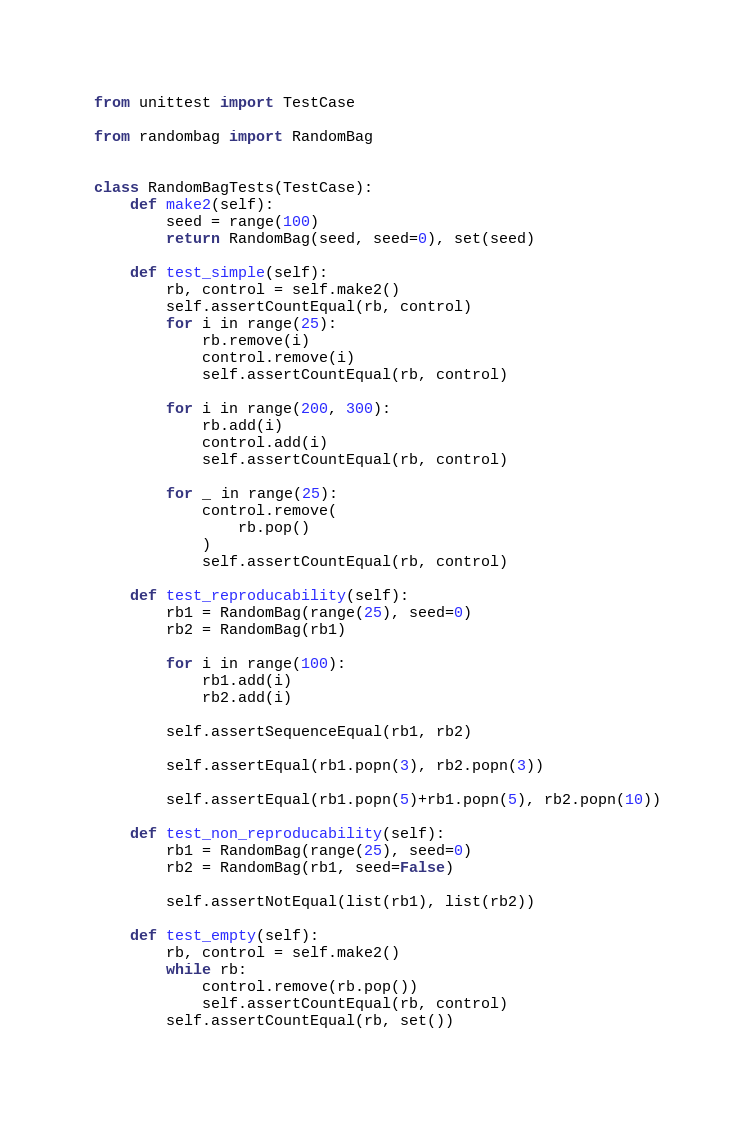Convert code to text. <code><loc_0><loc_0><loc_500><loc_500><_Python_>from unittest import TestCase

from randombag import RandomBag


class RandomBagTests(TestCase):
    def make2(self):
        seed = range(100)
        return RandomBag(seed, seed=0), set(seed)

    def test_simple(self):
        rb, control = self.make2()
        self.assertCountEqual(rb, control)
        for i in range(25):
            rb.remove(i)
            control.remove(i)
            self.assertCountEqual(rb, control)

        for i in range(200, 300):
            rb.add(i)
            control.add(i)
            self.assertCountEqual(rb, control)

        for _ in range(25):
            control.remove(
                rb.pop()
            )
            self.assertCountEqual(rb, control)

    def test_reproducability(self):
        rb1 = RandomBag(range(25), seed=0)
        rb2 = RandomBag(rb1)

        for i in range(100):
            rb1.add(i)
            rb2.add(i)

        self.assertSequenceEqual(rb1, rb2)

        self.assertEqual(rb1.popn(3), rb2.popn(3))

        self.assertEqual(rb1.popn(5)+rb1.popn(5), rb2.popn(10))

    def test_non_reproducability(self):
        rb1 = RandomBag(range(25), seed=0)
        rb2 = RandomBag(rb1, seed=False)

        self.assertNotEqual(list(rb1), list(rb2))

    def test_empty(self):
        rb, control = self.make2()
        while rb:
            control.remove(rb.pop())
            self.assertCountEqual(rb, control)
        self.assertCountEqual(rb, set())</code> 